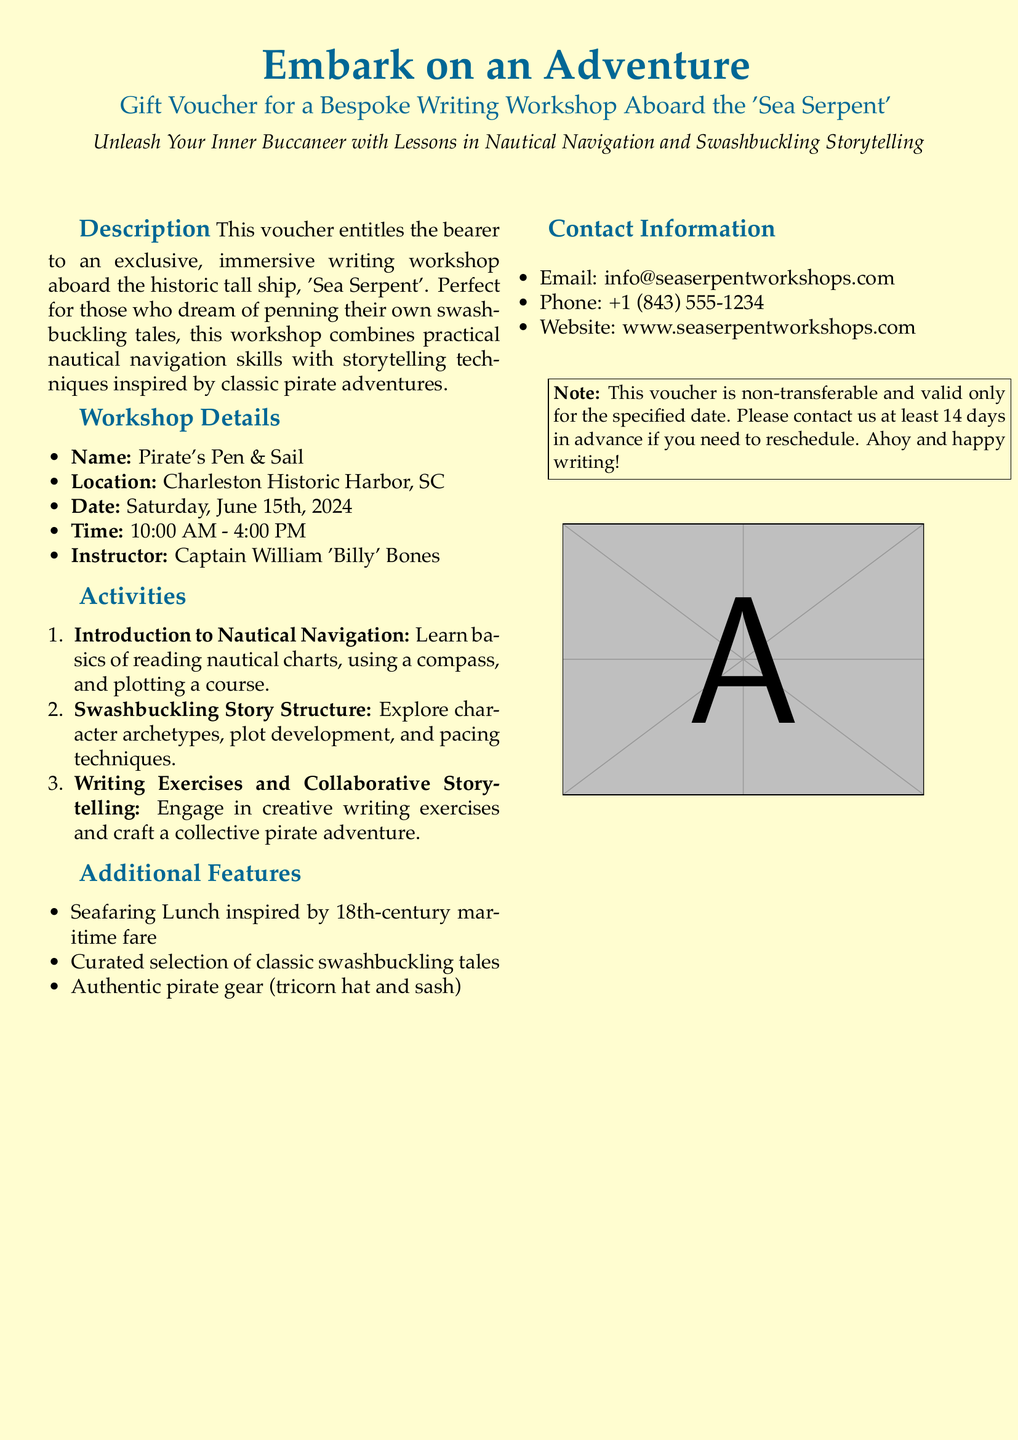What is the name of the workshop? The name of the workshop is explicitly mentioned in the document.
Answer: Pirate's Pen & Sail What is the location of the workshop? The document specifies the location where the workshop will take place.
Answer: Charleston Historic Harbor, SC When is the date of the workshop? The workshop date is clearly stated in the document.
Answer: June 15th, 2024 Who is the instructor of the workshop? The instructor's name is given in the workshop details section.
Answer: Captain William 'Billy' Bones What is the duration of the workshop? The time section provides the start and end times of the workshop.
Answer: 10:00 AM - 4:00 PM What type of lunch is included in the workshop? The document describes an additional feature regarding the lunch served.
Answer: Seafaring Lunch inspired by 18th-century maritime fare What skills will be taught during the workshop? The activities section outlines what will be covered in the workshop.
Answer: Nautical navigation and storytelling techniques What should you do if you need to reschedule? The note at the bottom provides instructions for rescheduling.
Answer: Contact us at least 14 days in advance Is this voucher transferable? There's a note in the document mentioning the transfer policy.
Answer: Non-transferable 